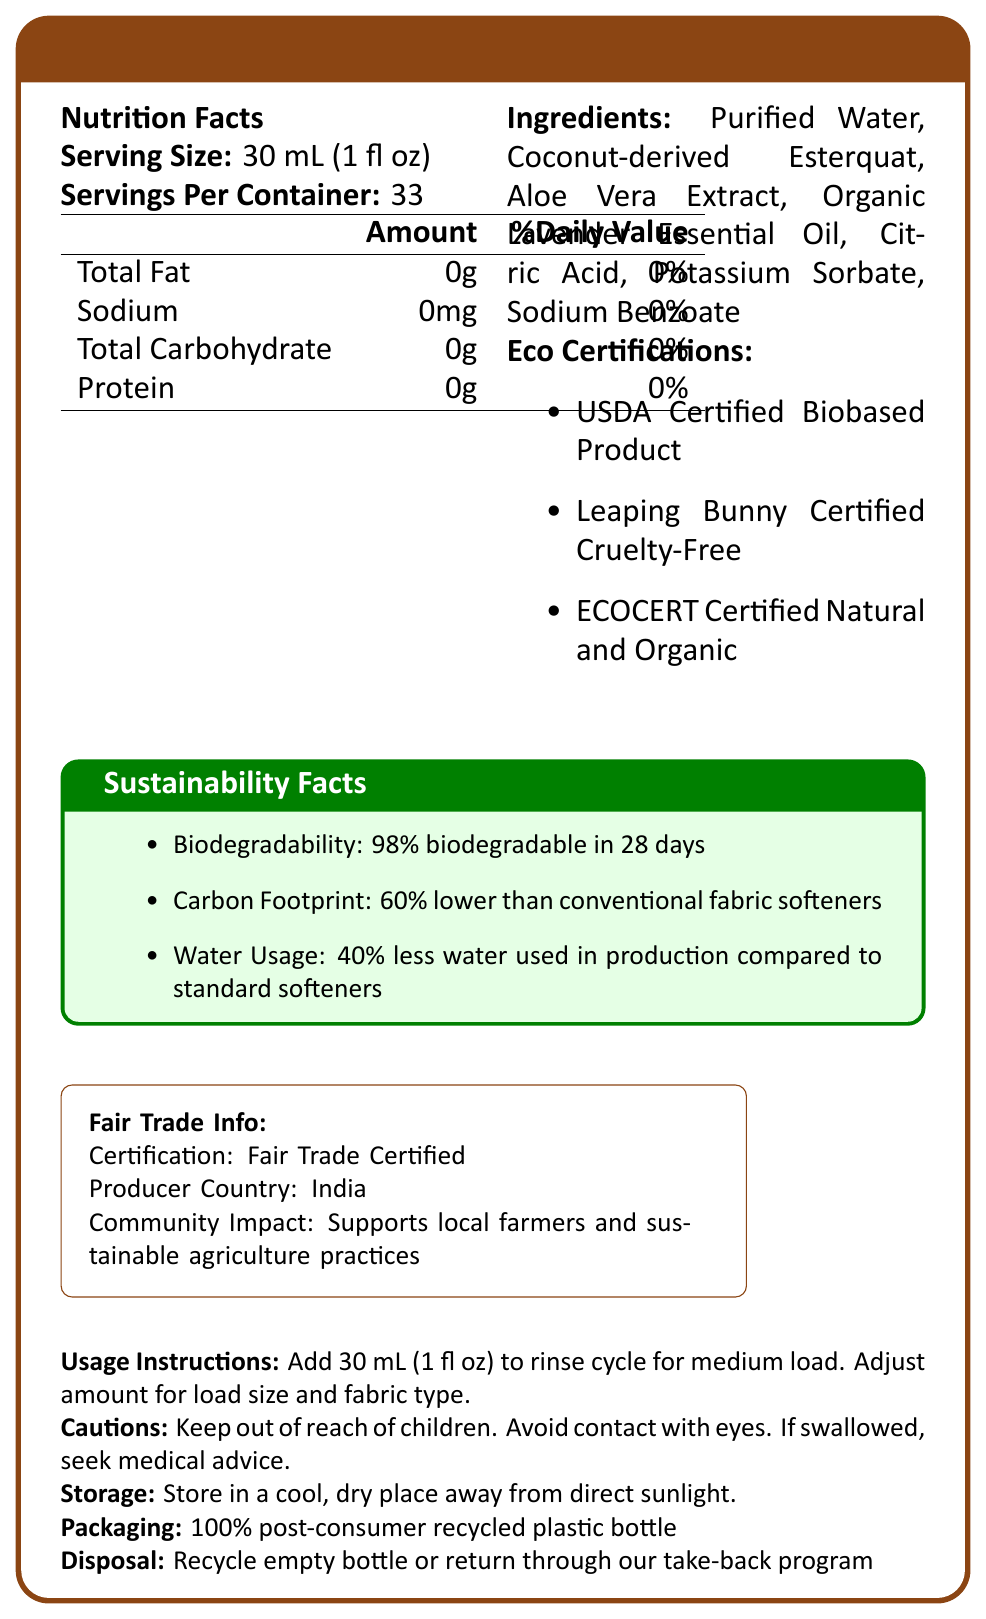What is the product name of the fabric softener? The product name is found at the top of the document in the title section.
Answer: EcoSoft Botanical Fabric Softener What is the serving size mentioned on the label? The serving size is clearly stated in the Nutrition Facts section.
Answer: 30 mL (1 fl oz) How many servings are there per container? The number of servings per container is listed under the Nutrition Facts section.
Answer: 33 List three ingredients used in the fabric softener. These ingredients are mentioned in the Ingredients section of the document.
Answer: Purified Water, Coconut-derived Esterquat, Aloe Vera Extract What percentage of the product is biodegradable within 28 days? The biodegradability percentage is noted in the Sustainability Facts section.
Answer: 98% How much sodium is in each serving? The Nutrition Facts section indicates that each serving contains 0mg of sodium.
Answer: 0mg Which of the following certifications does the product have? A. Fair Trade Certified B. USDA Certified Biobased Product C. Certified Organic by USDA D. All of the above The document mentions USDA Certified Biobased Product under the Eco Certifications section.
Answer: B What is the carbon footprint reduction of the product compared to conventional fabric softeners? A. 40% B. 50% C. 60% D. 70% The document states that the carbon footprint is 60% lower than conventional fabric softeners in the Sustainability Facts section.
Answer: C Is this product cruelty-free? The product is Leaping Bunny Certified Cruelty-Free as mentioned under the Eco Certifications section.
Answer: Yes What is one of the environmental benefits of this fabric softener? This environmental benefit is listed in the Sustainability Facts section.
Answer: It uses 40% less water in production compared to standard softeners. Which country is the producer of this fabric softener located in? The Fair Trade Info section specifies that the producer country is India.
Answer: India Describe the packaging used for this fabric softener. The Packaging section specifies the material used for the bottle.
Answer: The packaging is made of 100% post-consumer recycled plastic bottle. What should you do if the product is swallowed? The Cautions section advises seeking medical advice if the product is swallowed.
Answer: Seek medical advice Can the product bottle be recycled? The Disposal section mentions that the empty bottle should be recycled or returned through their take-back program.
Answer: Yes Summarize the main idea of the document. The document covers various aspects of the fabric softener, including its nutritional content, environmental and sustainability credentials, and usage and safety instructions.
Answer: The document provides information about EcoSoft Botanical Fabric Softener, highlighting its nutritional information, ingredients, eco-certifications, sustainability benefits, fair trade certification, usage instructions, cautions, storage guidelines, and packaging and disposal practices. What is the specific water usage reduction during production claimed by the product? This information is provided in the Sustainability Facts section.
Answer: 40% less water used in production compared to standard softeners What community impact is associated with the production of this fabric softener? This community impact is stated in the Fair Trade Info section.
Answer: Supports local farmers and sustainable agriculture practices What is the percentage of daily value for total fat per serving? The Nutrition Facts section lists the daily value percentage for total fat as 0%.
Answer: 0% What ingredient in the fabric softener helps with preservation? Both these ingredients are mentioned in the Ingredients section and are commonly used for preservation.
Answer: Potassium Sorbate or Sodium Benzoate How should the product be stored? The Storage section provides these instructions.
Answer: Store in a cool, dry place away from direct sunlight What is the impact on the daily diet of consuming this fabric softener? The product is not meant for consumption, and no information related to dietary impact is provided.
Answer: Not applicable or Cannot be determined 